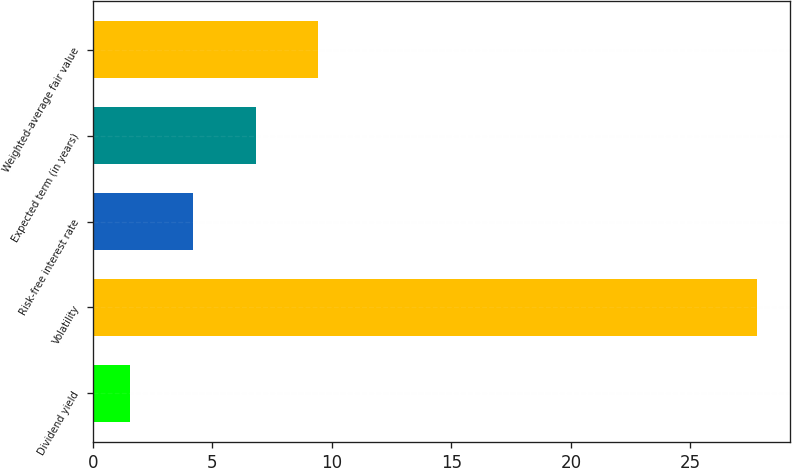<chart> <loc_0><loc_0><loc_500><loc_500><bar_chart><fcel>Dividend yield<fcel>Volatility<fcel>Risk-free interest rate<fcel>Expected term (in years)<fcel>Weighted-average fair value<nl><fcel>1.57<fcel>27.77<fcel>4.19<fcel>6.81<fcel>9.43<nl></chart> 